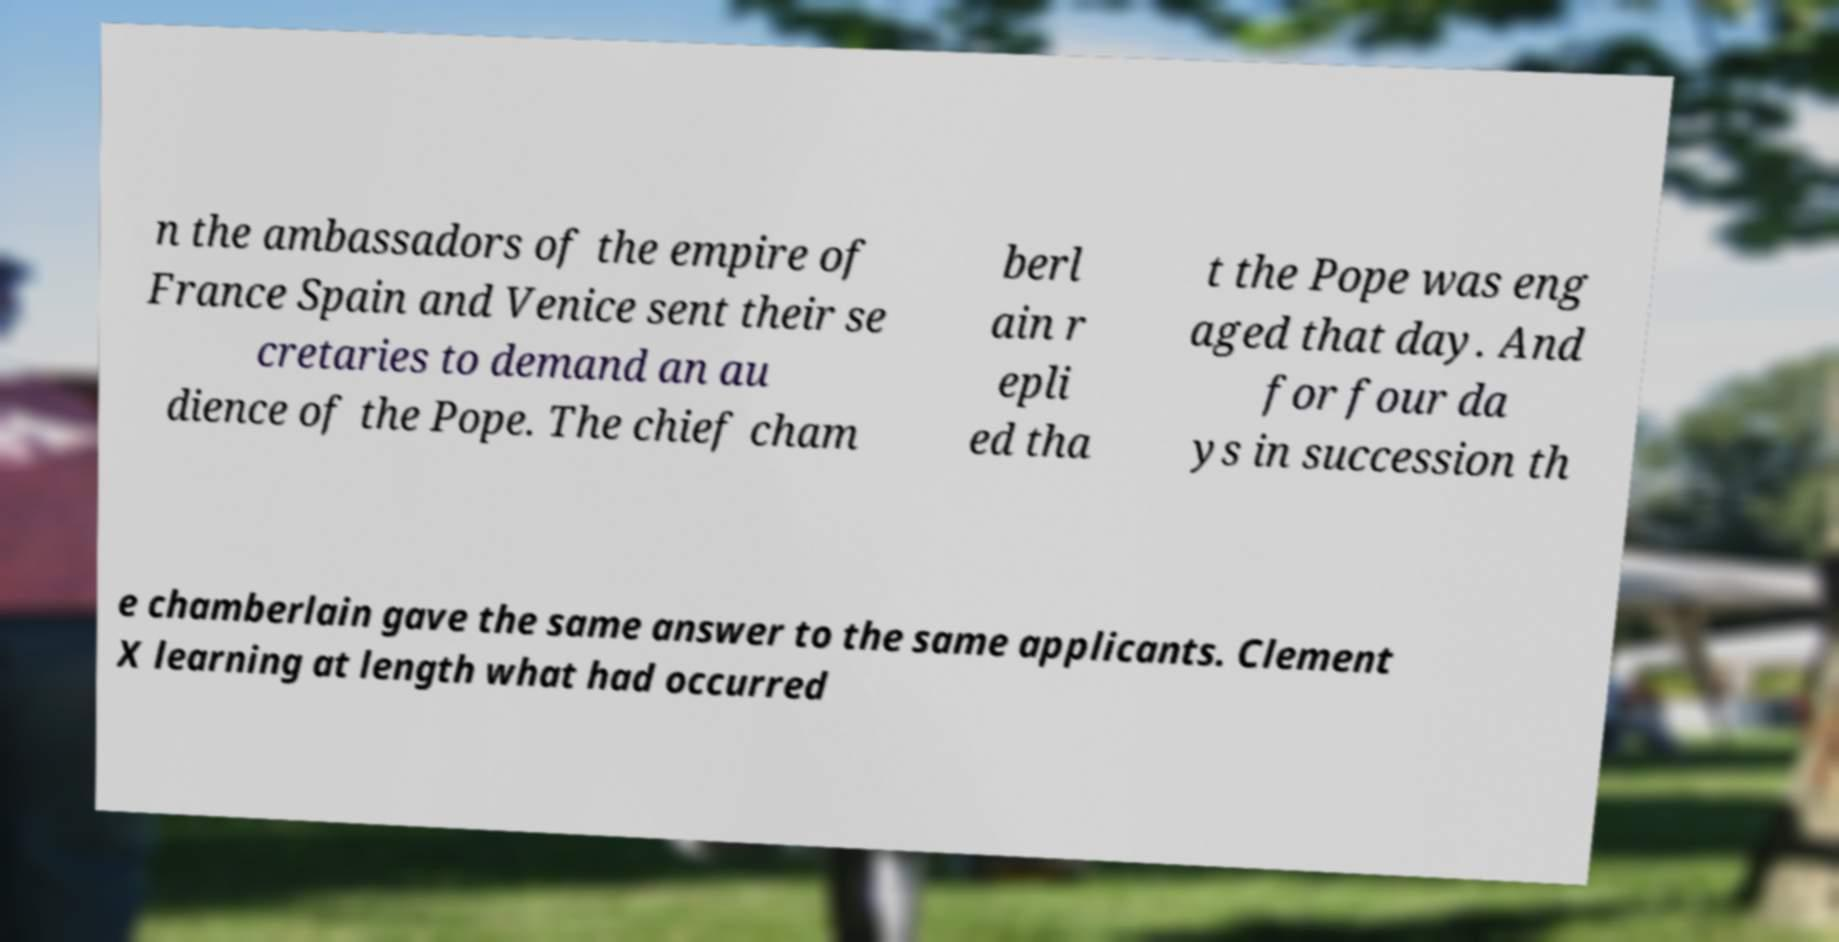Could you extract and type out the text from this image? n the ambassadors of the empire of France Spain and Venice sent their se cretaries to demand an au dience of the Pope. The chief cham berl ain r epli ed tha t the Pope was eng aged that day. And for four da ys in succession th e chamberlain gave the same answer to the same applicants. Clement X learning at length what had occurred 